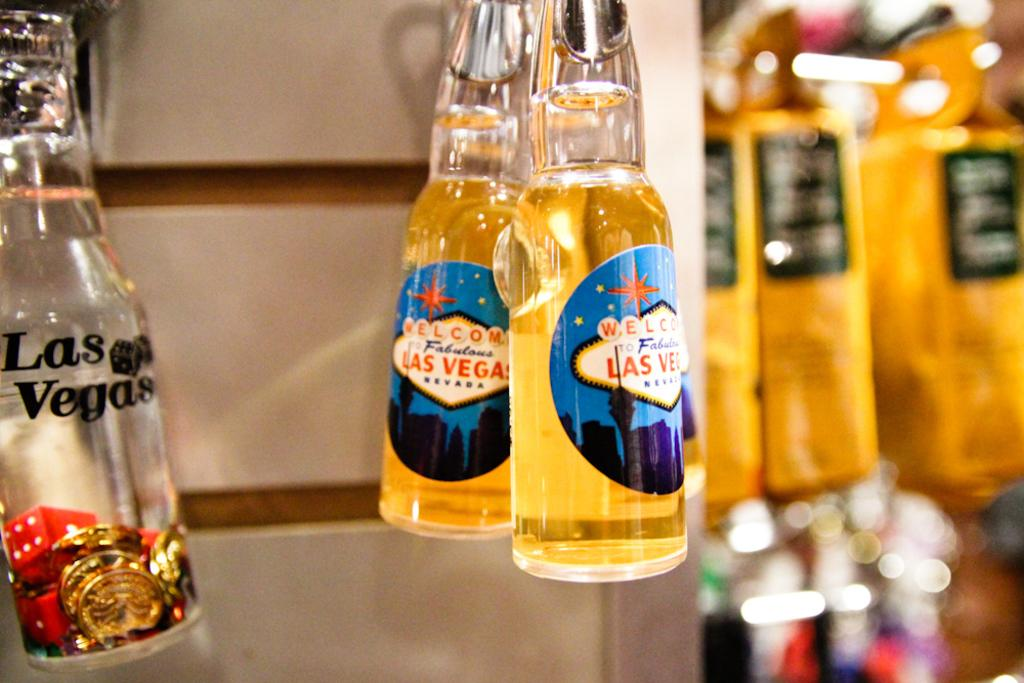<image>
Relay a brief, clear account of the picture shown. Lucite souvenier bottles with labels saying Las Vegas hang in a store. 